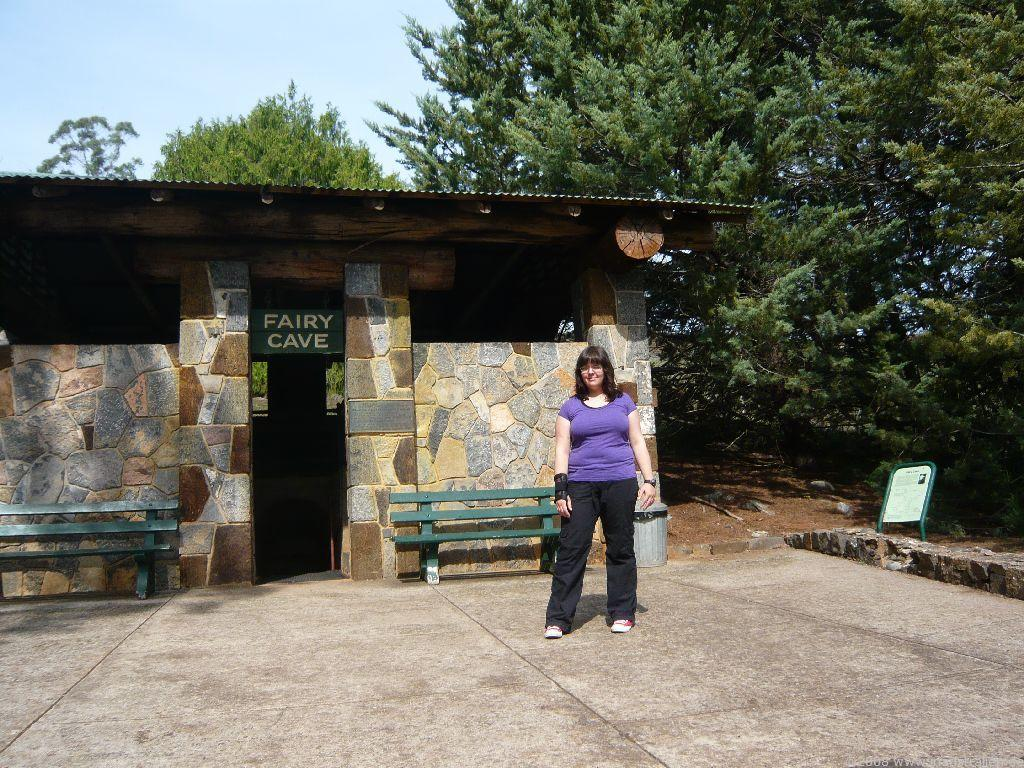What is the main subject of the image? The main subject of the image is a woman standing on the floor. What can be seen in the background of the image? In the background of the image, there is a shelter, benches, a name board, trees, and the sky. What type of structure is visible in the background? The shelter is visible in the background of the image. What might be used for seating in the background of the image? The benches in the background of the image might be used for seating. Where is the sofa located in the image? There is no sofa present in the image. What type of guide is assisting the woman in the image? There is no guide present in the image. Is there a bomb visible in the image? There is no bomb present in the image. 